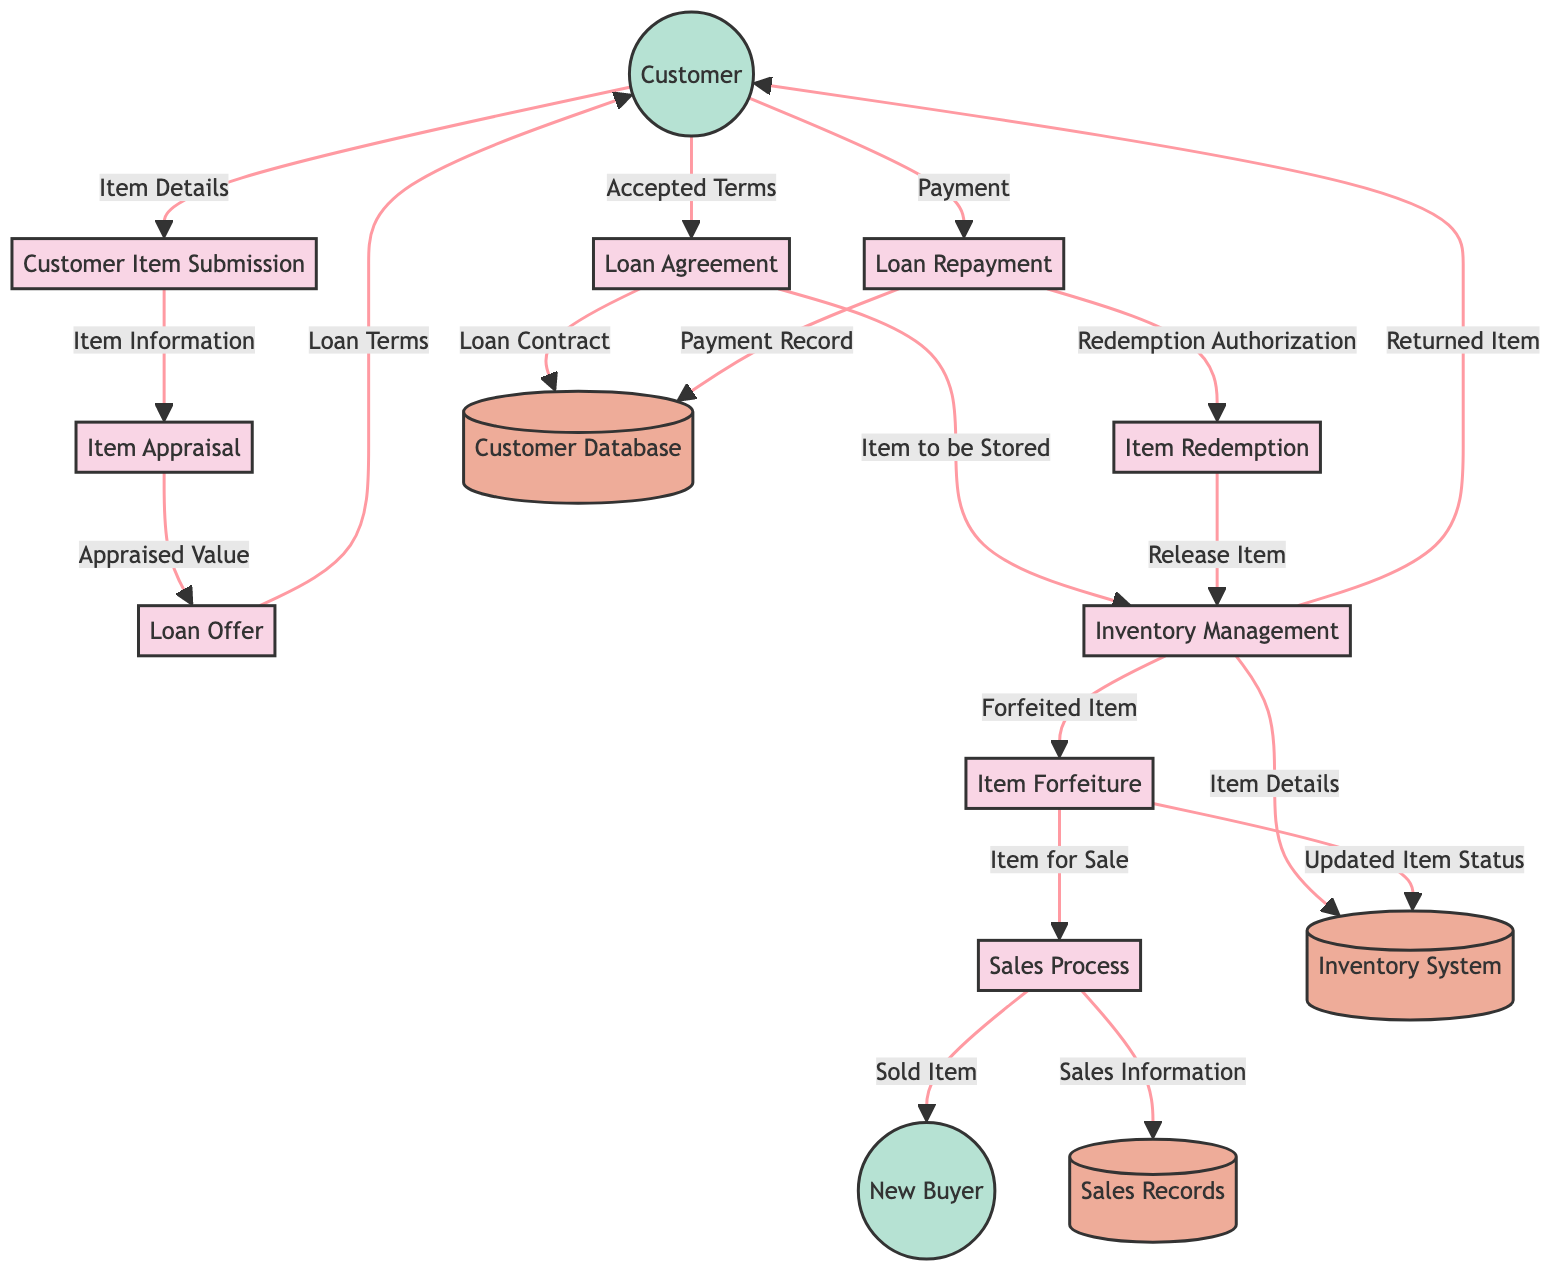What is the first process in the flow? The first process identified in the flow is "Customer Item Submission". It is the starting point where the customer brings an item to the pawn shop for appraisal.
Answer: Customer Item Submission How many data stores are present in the diagram? There are three data stores present in the diagram, which are labeled "Customer Database", "Inventory System", and "Sales Records".
Answer: 3 What does the "Loan Agreement" provide to the "Customer Database"? The "Loan Agreement" provides a "Loan Contract" to the "Customer Database". This is the data flow where the terms are officially recorded upon acceptance.
Answer: Loan Contract What item is logged into the "Inventory System"? The item logged into the "Inventory System" is referred to as "Item Details", which is received from "Inventory Management". This refers to the item being held as collateral.
Answer: Item Details What happens if the customer does not repay the loan? If the customer does not repay the loan, the process called "Item Forfeiture" occurs, where the item is forfeited and made available for sale.
Answer: Item Forfeiture What process follows the "Loan Repayment"? The process that follows "Loan Repayment" is called "Item Redemption", which occurs after the loan is repaid, allowing the customer to get their item back.
Answer: Item Redemption What does "Sales Process" send to "New Buyer"? The "Sales Process" sends a "Sold Item" to the "New Buyer", indicating the transaction that takes place when the forfeited item is sold.
Answer: Sold Item Which process leads to the "Item Appraisal"? The "Item Appraisal" is led by the process of "Customer Item Submission", which sends its information for evaluation. This establishes a sequence where item details are submitted first.
Answer: Customer Item Submission What is the final destination of the "Sales Information"? The "Sales Information" flows to the "Sales Records", which stores data regarding items sold, including those that are forfeited. This demonstrates the tracking of sales activity.
Answer: Sales Records 